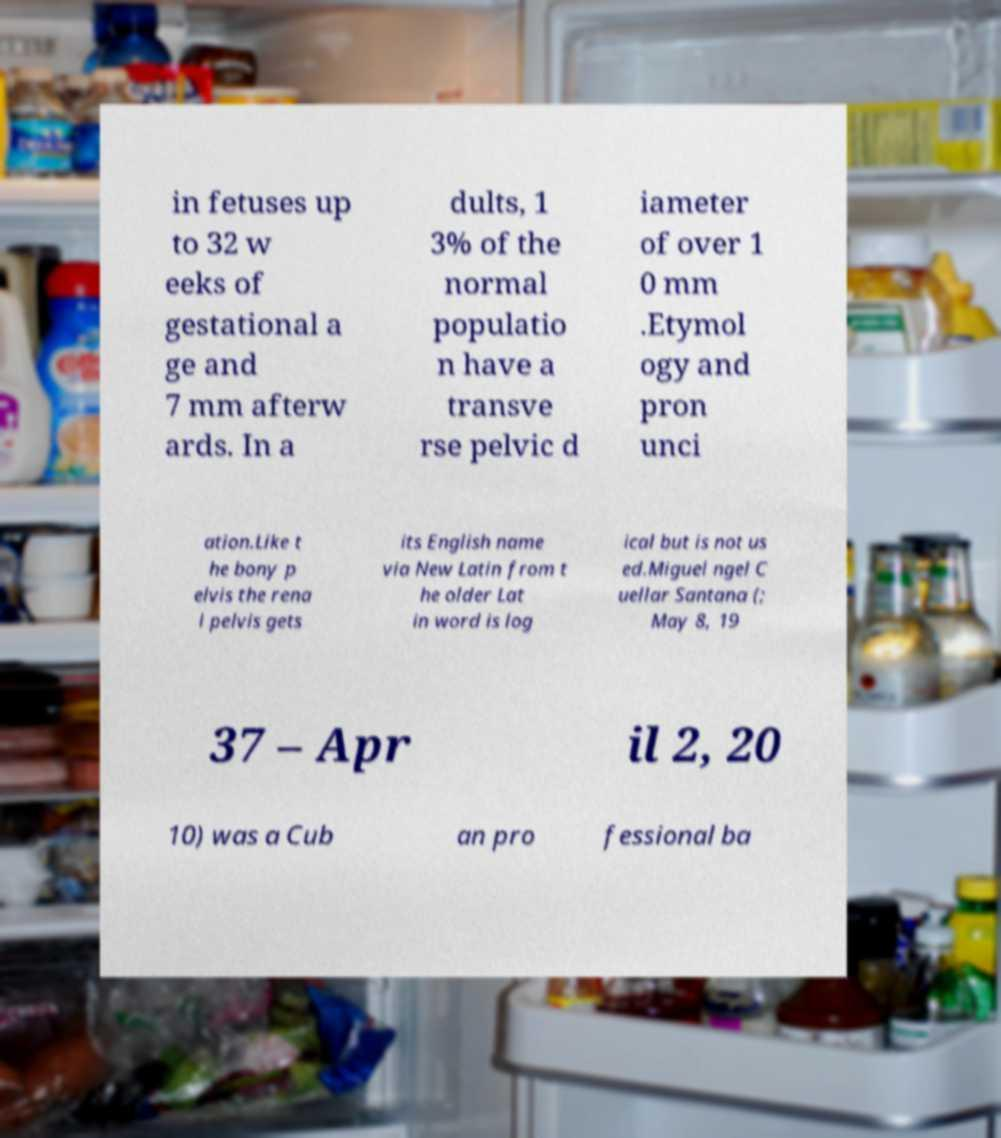Please identify and transcribe the text found in this image. in fetuses up to 32 w eeks of gestational a ge and 7 mm afterw ards. In a dults, 1 3% of the normal populatio n have a transve rse pelvic d iameter of over 1 0 mm .Etymol ogy and pron unci ation.Like t he bony p elvis the rena l pelvis gets its English name via New Latin from t he older Lat in word is log ical but is not us ed.Miguel ngel C uellar Santana (; May 8, 19 37 – Apr il 2, 20 10) was a Cub an pro fessional ba 